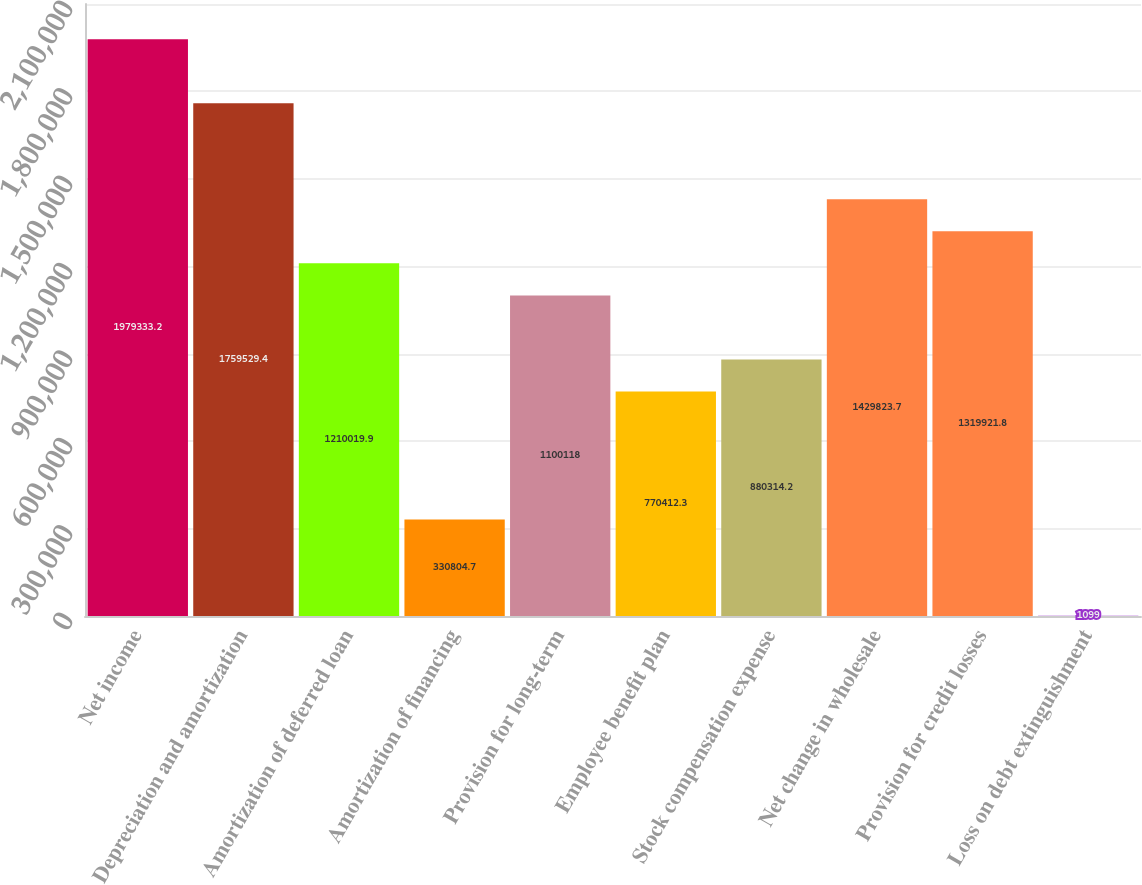<chart> <loc_0><loc_0><loc_500><loc_500><bar_chart><fcel>Net income<fcel>Depreciation and amortization<fcel>Amortization of deferred loan<fcel>Amortization of financing<fcel>Provision for long-term<fcel>Employee benefit plan<fcel>Stock compensation expense<fcel>Net change in wholesale<fcel>Provision for credit losses<fcel>Loss on debt extinguishment<nl><fcel>1.97933e+06<fcel>1.75953e+06<fcel>1.21002e+06<fcel>330805<fcel>1.10012e+06<fcel>770412<fcel>880314<fcel>1.42982e+06<fcel>1.31992e+06<fcel>1099<nl></chart> 